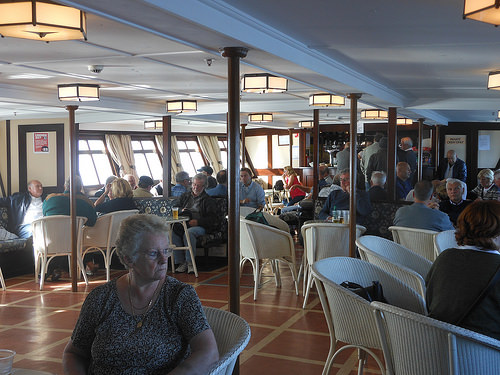<image>
Can you confirm if the woman is in front of the chair? Yes. The woman is positioned in front of the chair, appearing closer to the camera viewpoint. 